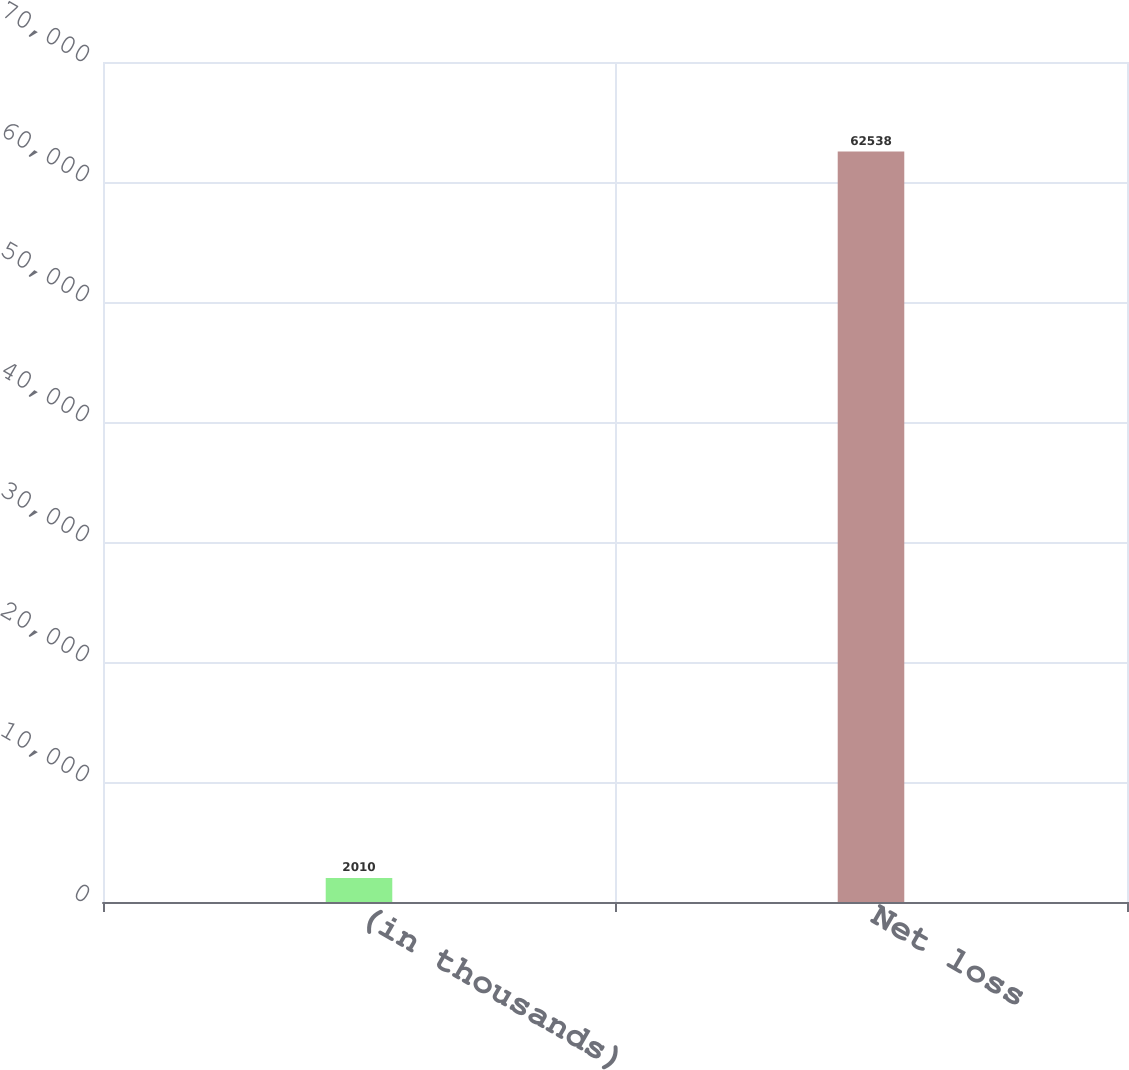Convert chart to OTSL. <chart><loc_0><loc_0><loc_500><loc_500><bar_chart><fcel>(in thousands)<fcel>Net loss<nl><fcel>2010<fcel>62538<nl></chart> 